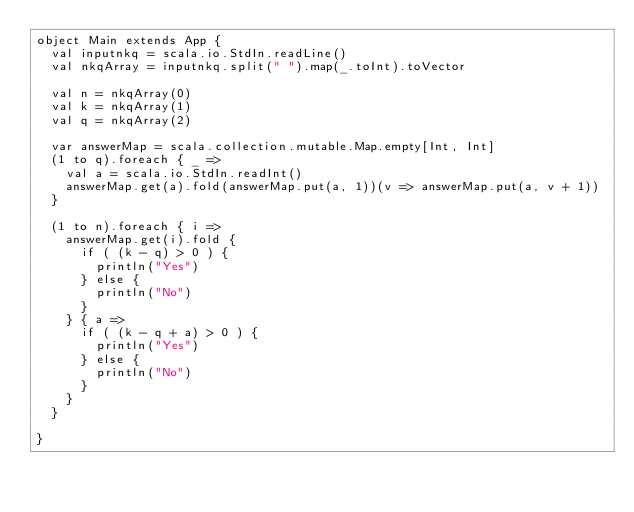<code> <loc_0><loc_0><loc_500><loc_500><_Scala_>object Main extends App {
  val inputnkq = scala.io.StdIn.readLine()
  val nkqArray = inputnkq.split(" ").map(_.toInt).toVector

  val n = nkqArray(0)
  val k = nkqArray(1)
  val q = nkqArray(2)

  var answerMap = scala.collection.mutable.Map.empty[Int, Int]
  (1 to q).foreach { _ =>
    val a = scala.io.StdIn.readInt()
    answerMap.get(a).fold(answerMap.put(a, 1))(v => answerMap.put(a, v + 1))
  }

  (1 to n).foreach { i =>
    answerMap.get(i).fold {
      if ( (k - q) > 0 ) {
        println("Yes")
      } else {
        println("No")
      }
    } { a =>
      if ( (k - q + a) > 0 ) {
        println("Yes")
      } else {
        println("No")
      }
    }
  }

}</code> 